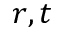<formula> <loc_0><loc_0><loc_500><loc_500>r , t</formula> 